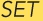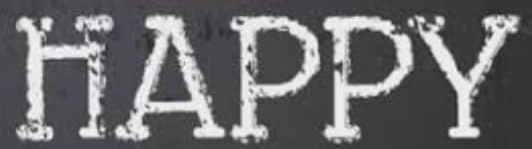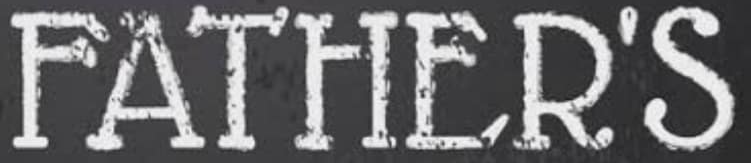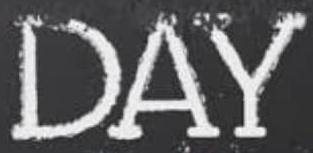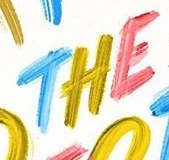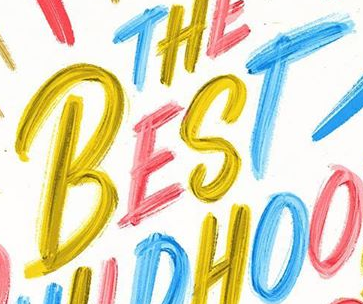Transcribe the words shown in these images in order, separated by a semicolon. SET; HAPPY; FATHER'S; DAY; THE; BEST 